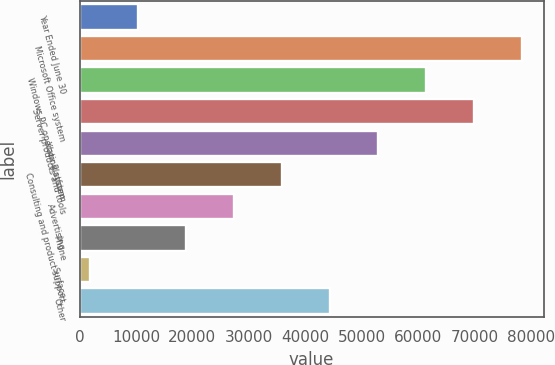<chart> <loc_0><loc_0><loc_500><loc_500><bar_chart><fcel>Year Ended June 30<fcel>Microsoft Office system<fcel>Windows PC operating system<fcel>Server products and tools<fcel>Xbox Platform<fcel>Consulting and product support<fcel>Advertising<fcel>Phone<fcel>Surface<fcel>Other<nl><fcel>10378<fcel>78338<fcel>61348<fcel>69843<fcel>52853<fcel>35863<fcel>27368<fcel>18873<fcel>1883<fcel>44358<nl></chart> 